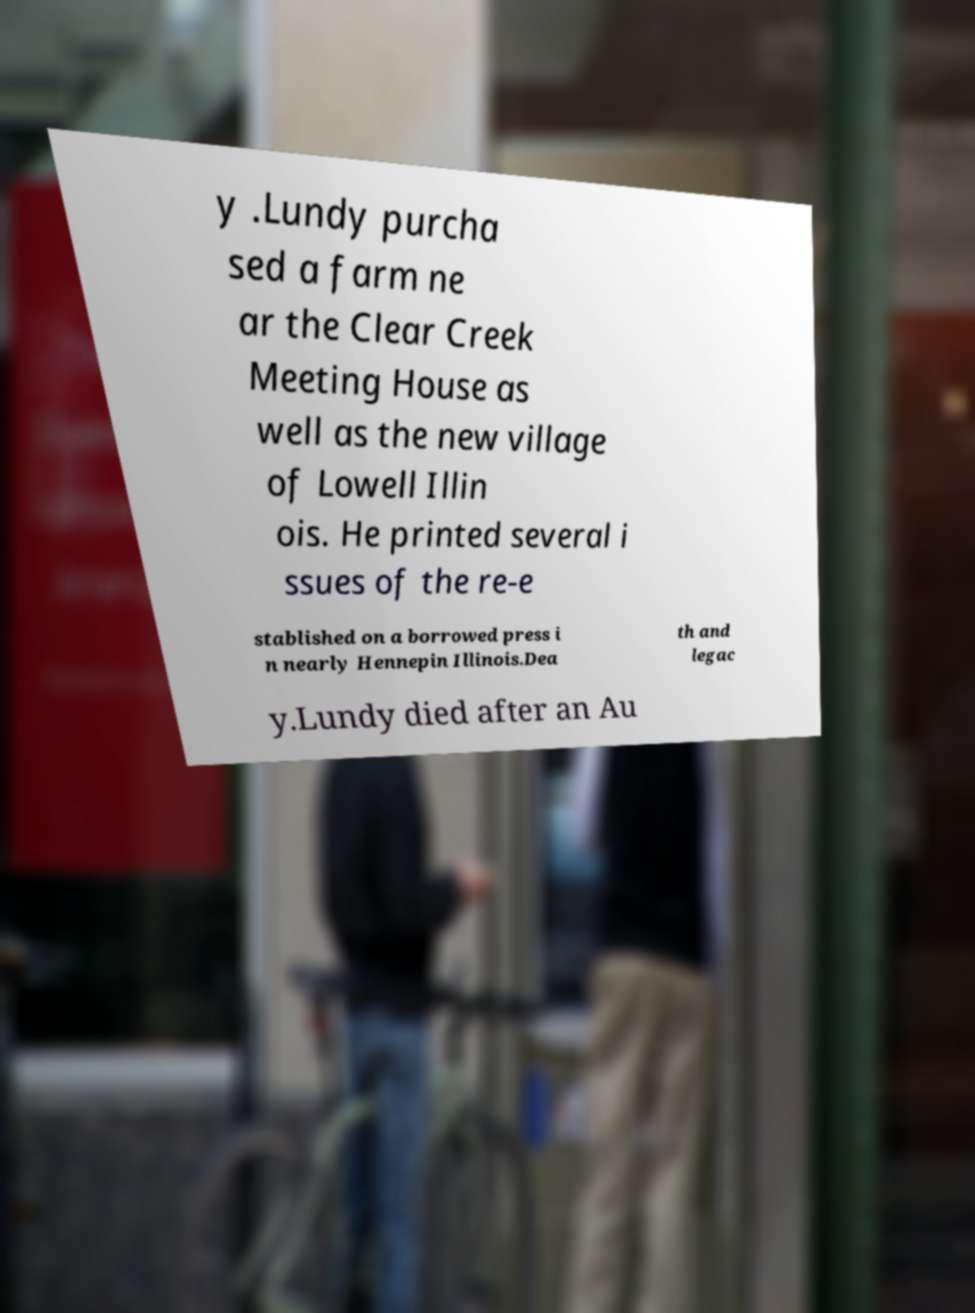There's text embedded in this image that I need extracted. Can you transcribe it verbatim? y .Lundy purcha sed a farm ne ar the Clear Creek Meeting House as well as the new village of Lowell Illin ois. He printed several i ssues of the re-e stablished on a borrowed press i n nearly Hennepin Illinois.Dea th and legac y.Lundy died after an Au 